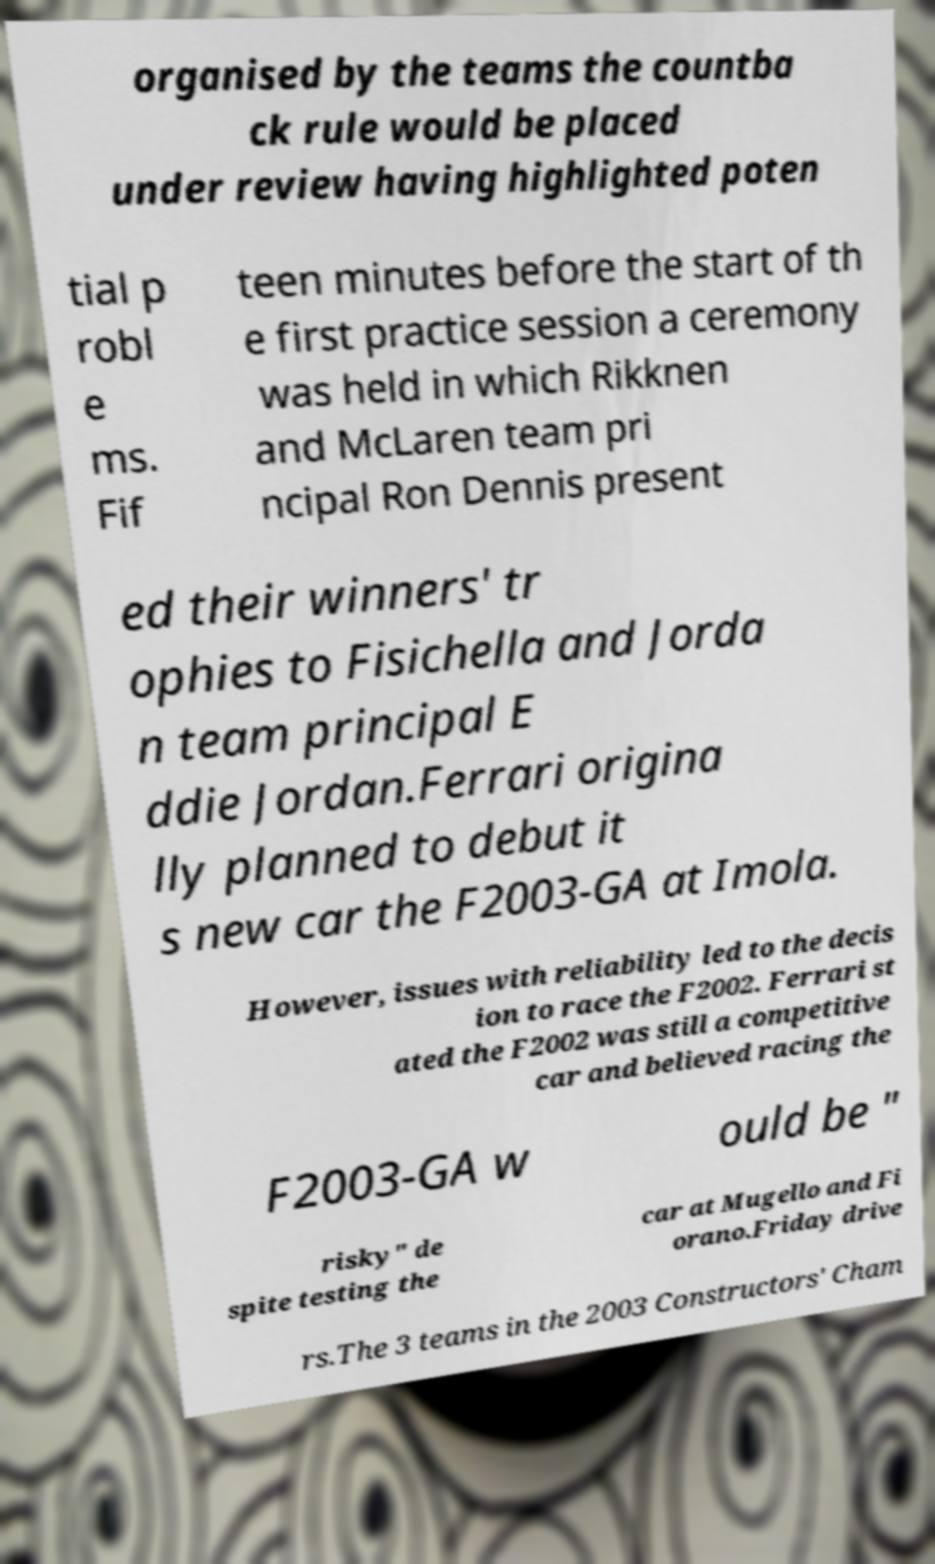For documentation purposes, I need the text within this image transcribed. Could you provide that? organised by the teams the countba ck rule would be placed under review having highlighted poten tial p robl e ms. Fif teen minutes before the start of th e first practice session a ceremony was held in which Rikknen and McLaren team pri ncipal Ron Dennis present ed their winners' tr ophies to Fisichella and Jorda n team principal E ddie Jordan.Ferrari origina lly planned to debut it s new car the F2003-GA at Imola. However, issues with reliability led to the decis ion to race the F2002. Ferrari st ated the F2002 was still a competitive car and believed racing the F2003-GA w ould be " risky" de spite testing the car at Mugello and Fi orano.Friday drive rs.The 3 teams in the 2003 Constructors' Cham 